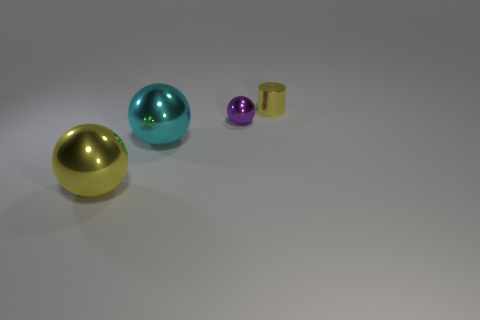What number of other objects are the same material as the tiny yellow thing?
Keep it short and to the point. 3. What number of metal things are in front of the small purple metal sphere?
Your answer should be very brief. 2. How many blocks are big yellow shiny objects or tiny shiny objects?
Your answer should be compact. 0. How big is the metal ball that is in front of the purple shiny thing and behind the big yellow sphere?
Your response must be concise. Large. How many other things are the same color as the metal cylinder?
Offer a very short reply. 1. Do the cylinder and the small thing that is in front of the yellow metal cylinder have the same material?
Make the answer very short. Yes. What number of things are things that are to the right of the yellow metallic sphere or big objects?
Your answer should be compact. 4. There is a cyan ball that is the same material as the tiny yellow cylinder; what is its size?
Your response must be concise. Large. How many things are yellow things left of the cyan object or large things that are in front of the large cyan metallic thing?
Your answer should be compact. 1. There is a metal thing that is right of the purple ball; is its size the same as the large cyan metal thing?
Provide a succinct answer. No. 